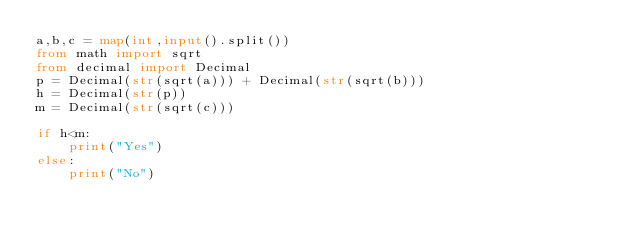Convert code to text. <code><loc_0><loc_0><loc_500><loc_500><_Python_>a,b,c = map(int,input().split())
from math import sqrt
from decimal import Decimal
p = Decimal(str(sqrt(a))) + Decimal(str(sqrt(b)))
h = Decimal(str(p))
m = Decimal(str(sqrt(c)))

if h<m:
    print("Yes")
else:
    print("No")</code> 